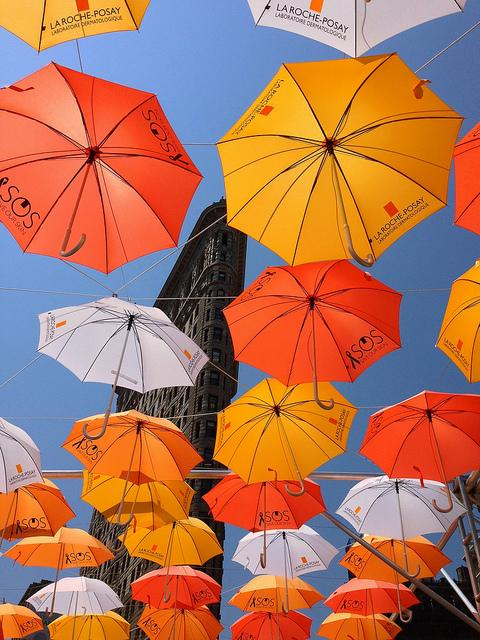What larger makeup group owns this company?

Choices:
A) maybelline
B) cover girl
C) l'oreal
D) lancome l'oreal 